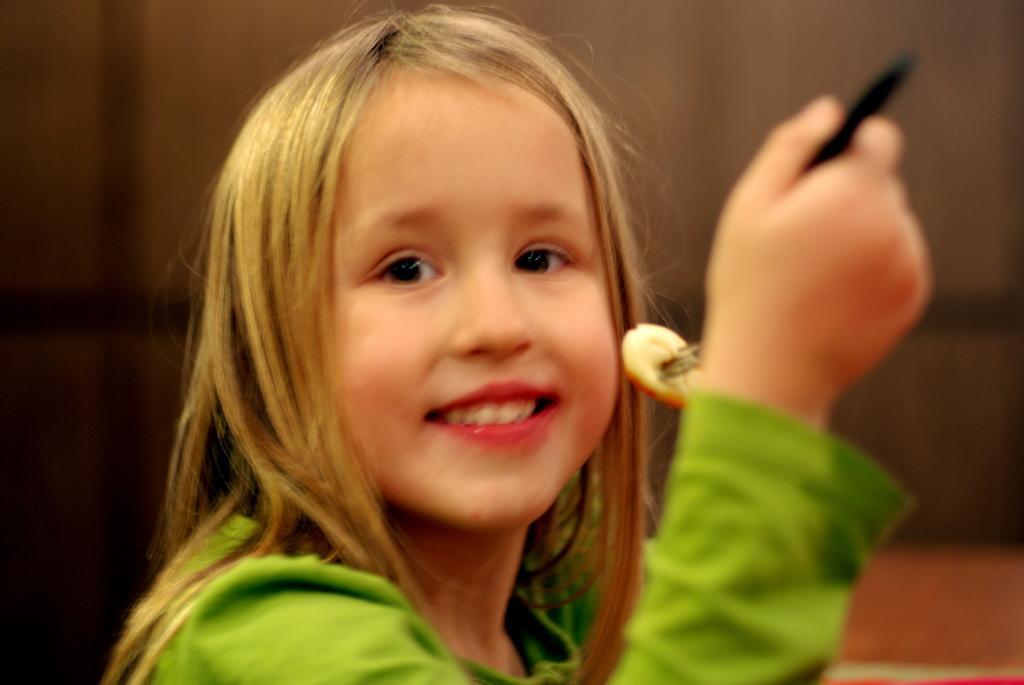Describe this image in one or two sentences. In this image I can see a girl is holding the food with the fork, she wore a green color t-shirt and also smiling. 